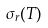Convert formula to latex. <formula><loc_0><loc_0><loc_500><loc_500>\sigma _ { r } ( T )</formula> 